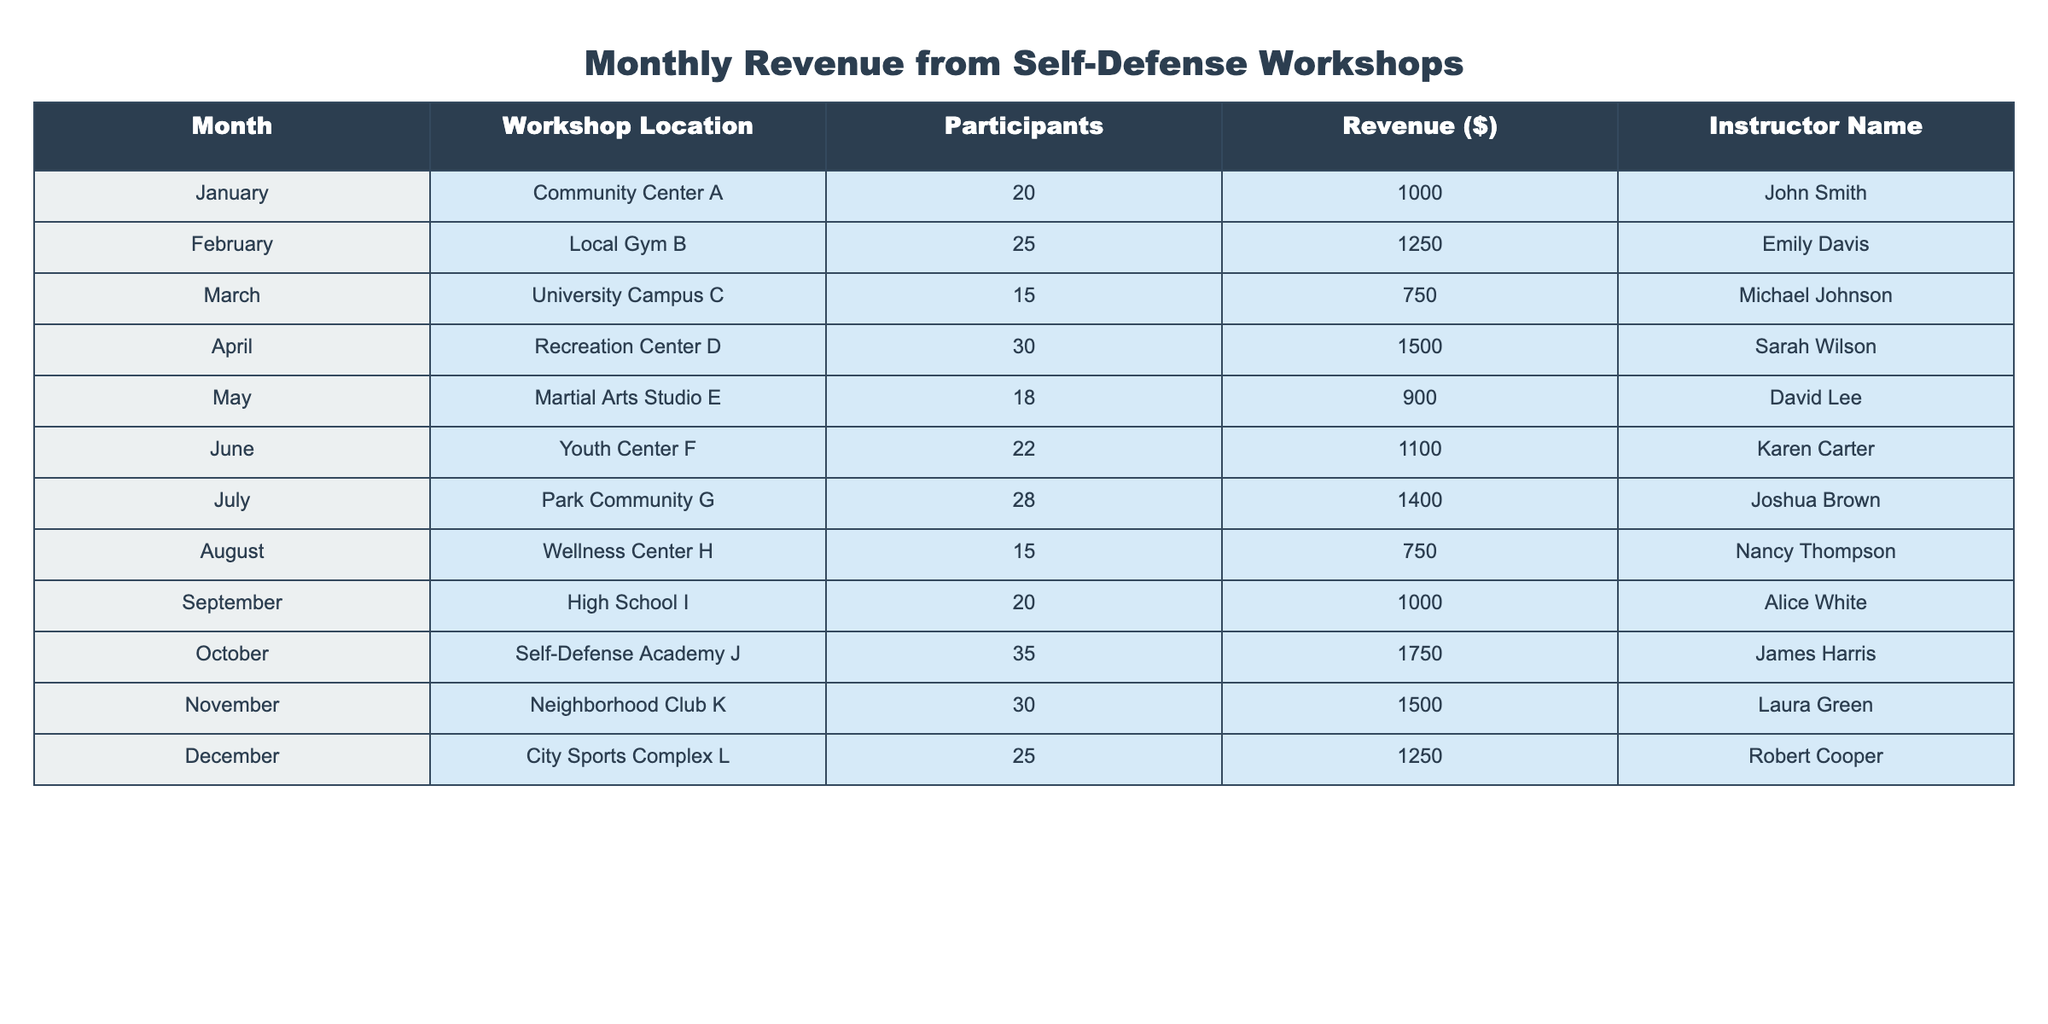What was the revenue for October? The revenue for October is listed under the corresponding month in the table, which shows a revenue of $1750
Answer: $1750 How many participants attended the workshop at the Recreation Center D in April? The number of participants for April is directly provided in the table, which indicates 30 participants
Answer: 30 What is the total revenue generated from all workshops in the year? To find the total revenue, add all revenue values: 1000 + 1250 + 750 + 1500 + 900 + 1100 + 1400 + 750 + 1000 + 1750 + 1500 + 1250 = 13600
Answer: $13600 Who had the highest number of participants and what was that number? The month with the highest number of participants can be found by comparing the participant counts. October has the highest at 35 participants.
Answer: 35 participants Was there a workshop in the summer months (June, July, August)? Yes, all three summer months had workshops, as listed in the table with their respective data
Answer: Yes What is the average revenue per workshop across the twelve months? Total revenue is $13600; dividing this by the number of workshops (12) gives the average: 13600 / 12 = 1133.33
Answer: $1133.33 Has the revenue ever dropped below $1000 in any month? By examining the revenue for each month, it's clear that the revenue for March and August was $750, which is below $1000
Answer: Yes Which instructor taught the most participants in a single month, and how many were there? Checking the table, October had the highest participation (35) under instructor James Harris, making him the instructor with the most participants
Answer: James Harris, 35 participants What was the difference in revenue between the highest and lowest months? The highest revenue was $1750 (October) and the lowest was $750 (March and August), so the difference is $1750 - $750 = $1000
Answer: $1000 How many workshops generated a revenue greater than $1000? By analyzing the revenue column, the months with revenue greater than $1000 are: February, April, July, October, November, totaling 6 workshops
Answer: 6 